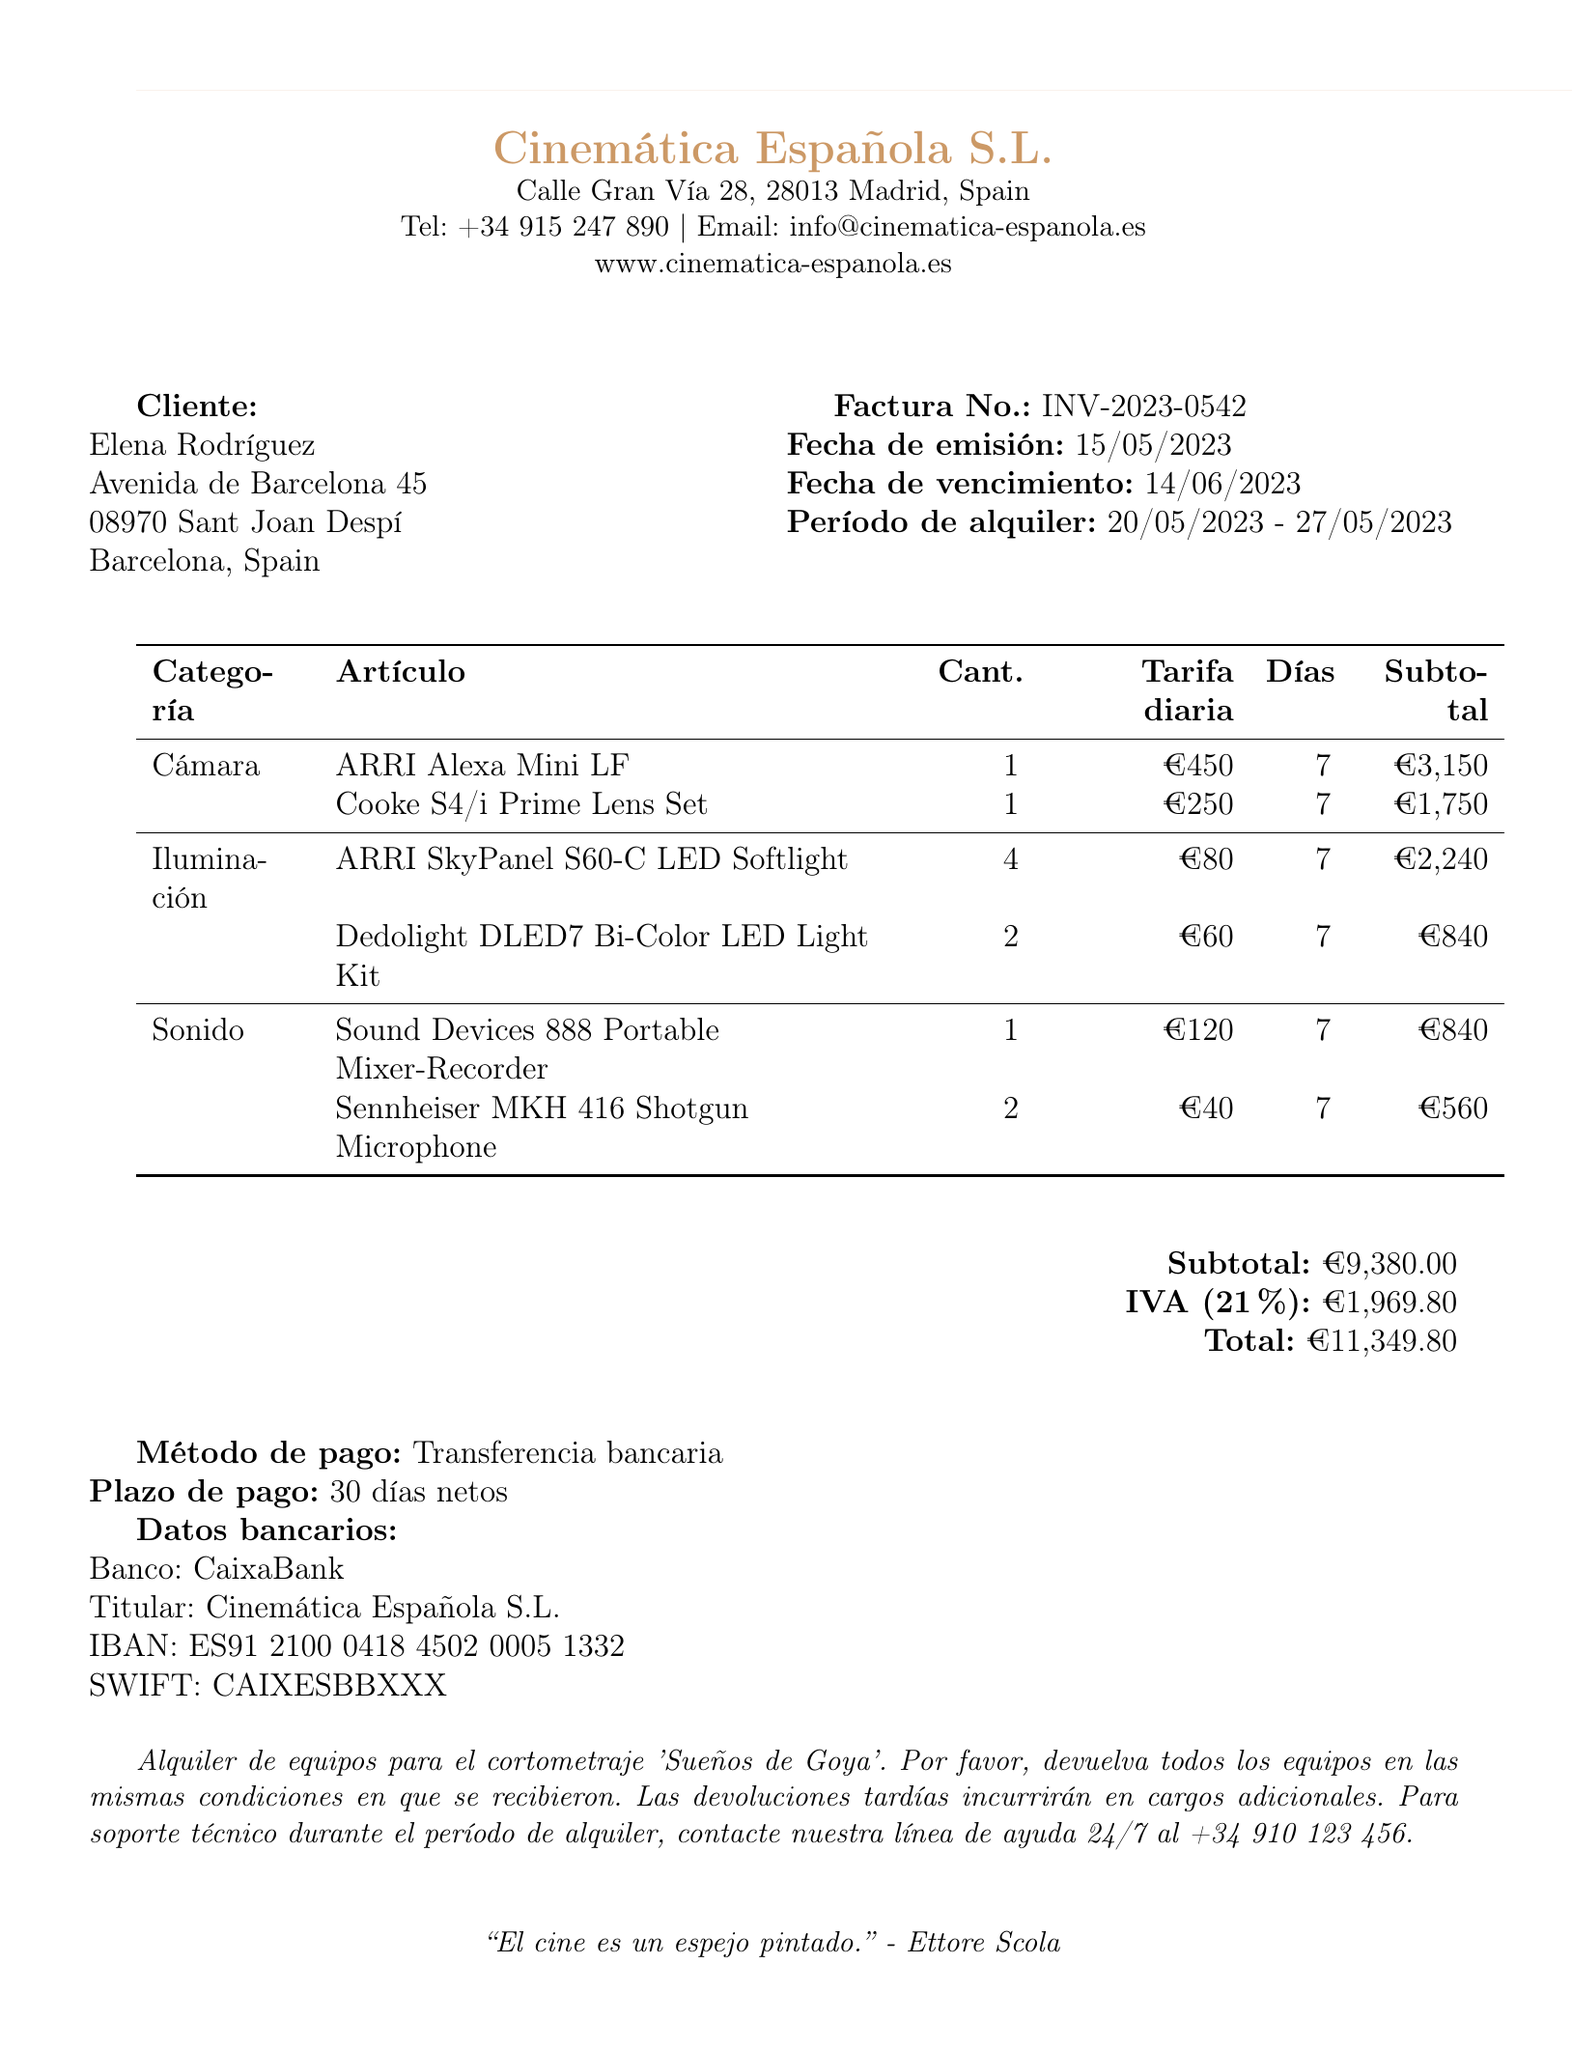What is the invoice number? The invoice number is specified prominently at the top of the document.
Answer: INV-2023-0542 What is the total amount due? The total amount is calculated by adding the subtotal and tax amount.
Answer: €11,349.80 Who is the customer? The customer's name appears at the beginning of the document, under the client section.
Answer: Elena Rodríguez What is the rental period? The rental period is stated clearly in the document, indicating the start and end dates.
Answer: 2023-05-20 to 2023-05-27 How many ARRI SkyPanel S60-C LED Softlights are rented? The quantity of ARRI SkyPanel S60-C LED Softlights is listed under the lighting equipment section.
Answer: 4 What is the subtotal before tax? The subtotal is listed before the tax information in the summary section of the document.
Answer: €9,380.00 What tax rate is applied? The tax rate is mentioned in the financial summary of the document.
Answer: 21 What payment method is specified? The payment method is described in the payment section of the invoice.
Answer: Bank transfer Who is the rental company? The rental company’s name is prominently displayed at the top of the document.
Answer: Cinemática Española S.L 